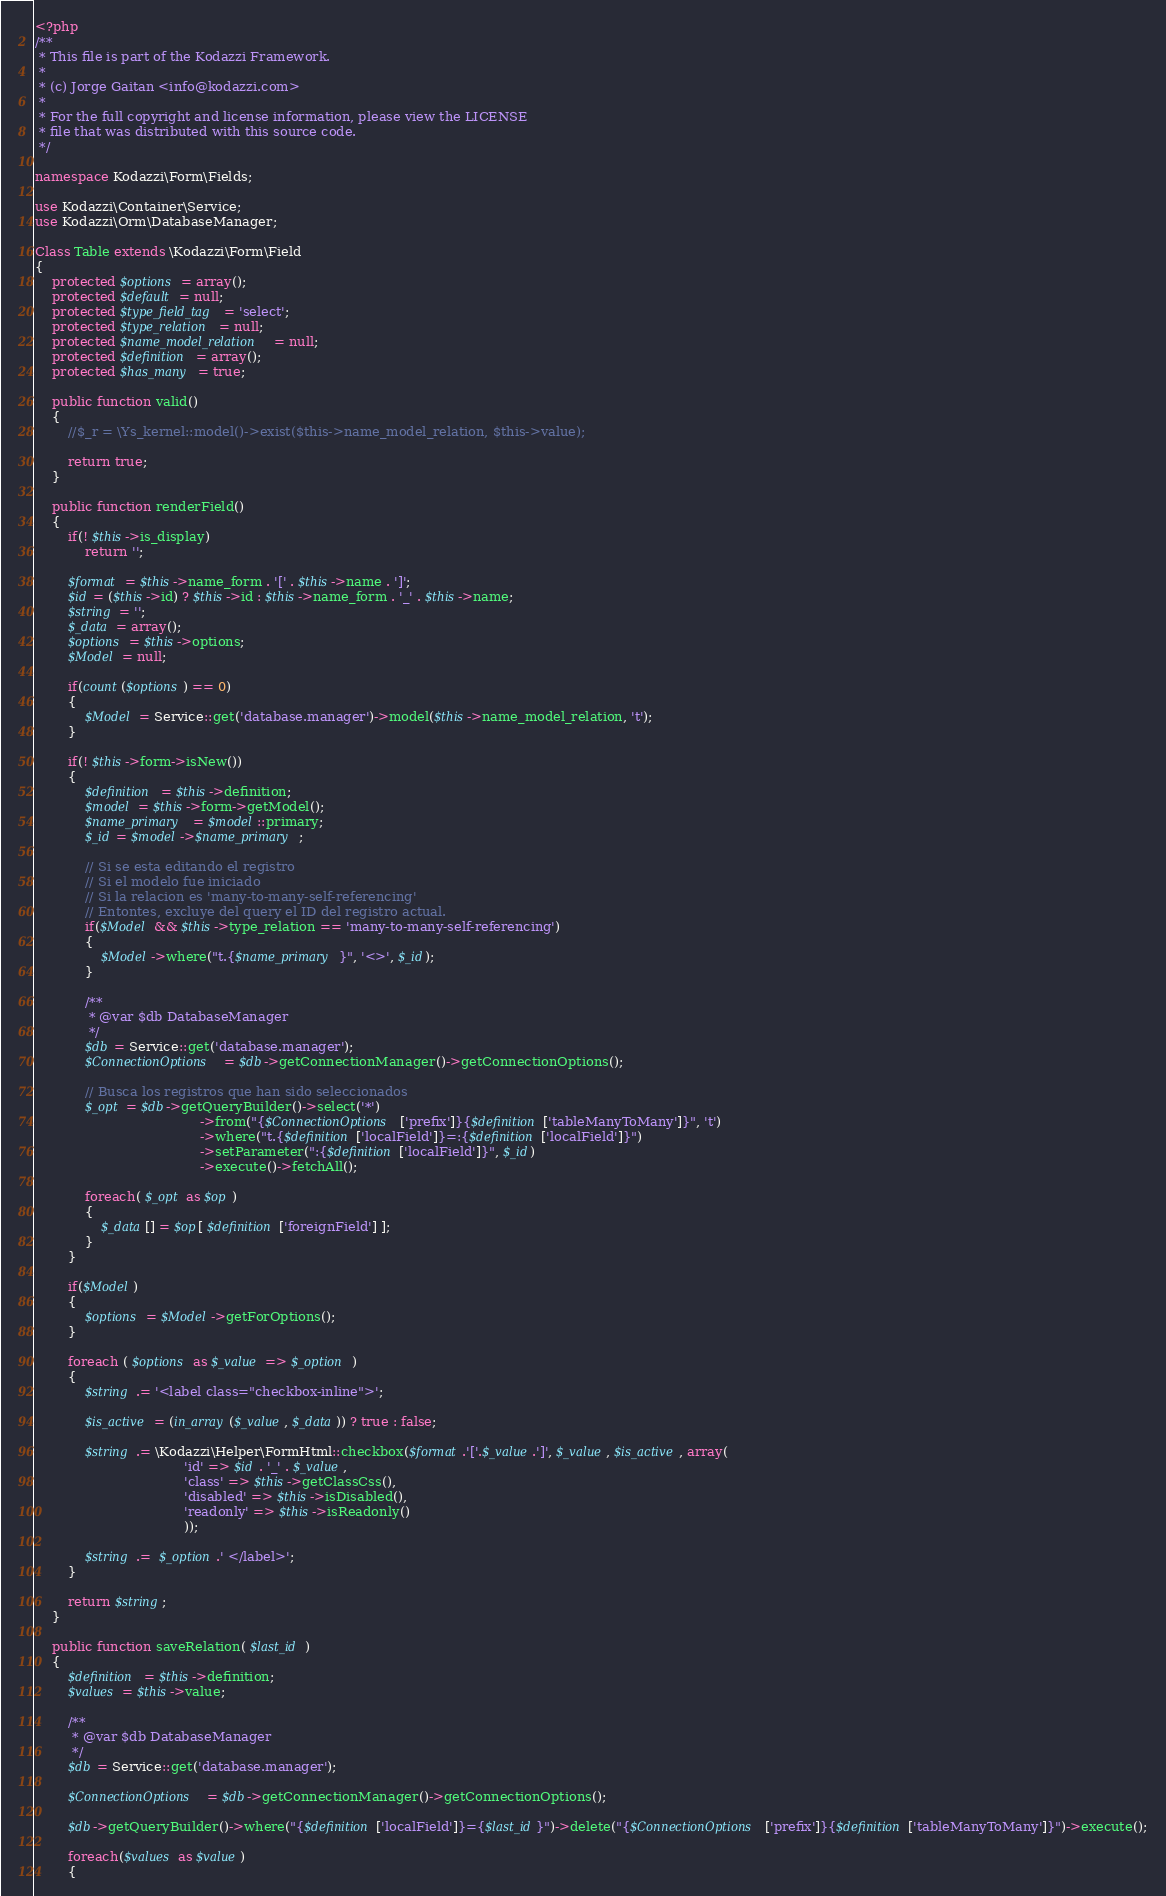<code> <loc_0><loc_0><loc_500><loc_500><_PHP_><?php
/**
 * This file is part of the Kodazzi Framework.
 *
 * (c) Jorge Gaitan <info@kodazzi.com>
 *
 * For the full copyright and license information, please view the LICENSE
 * file that was distributed with this source code.
 */

namespace Kodazzi\Form\Fields;

use Kodazzi\Container\Service;
use Kodazzi\Orm\DatabaseManager;

Class Table extends \Kodazzi\Form\Field
{
	protected $options = array();
	protected $default = null;
	protected $type_field_tag = 'select';
	protected $type_relation = null;
	protected $name_model_relation = null;
	protected $definition = array();
	protected $has_many = true;

	public function valid()
	{
		//$_r = \Ys_kernel::model()->exist($this->name_model_relation, $this->value);
		
		return true;
	}

	public function renderField()
	{
		if(! $this->is_display)
			return '';

		$format = $this->name_form . '[' . $this->name . ']';
        $id = ($this->id) ? $this->id : $this->name_form . '_' . $this->name;
		$string = '';
		$_data = array();
		$options = $this->options;
        $Model = null;

		if(count($options) == 0)
		{
            $Model = Service::get('database.manager')->model($this->name_model_relation, 't');
		}

		if(! $this->form->isNew())
		{
            $definition = $this->definition;
            $model = $this->form->getModel();
            $name_primary = $model::primary;
            $_id = $model->$name_primary;

            // Si se esta editando el registro
            // Si el modelo fue iniciado
            // Si la relacion es 'many-to-many-self-referencing'
            // Entontes, excluye del query el ID del registro actual.
            if($Model && $this->type_relation == 'many-to-many-self-referencing')
            {
                $Model->where("t.{$name_primary}", '<>', $_id);
            }

            /**
             * @var $db DatabaseManager
             */
            $db = Service::get('database.manager');
            $ConnectionOptions = $db->getConnectionManager()->getConnectionOptions();

            // Busca los registros que han sido seleccionados
            $_opt = $db->getQueryBuilder()->select('*')
                                        ->from("{$ConnectionOptions['prefix']}{$definition['tableManyToMany']}", 't')
                                        ->where("t.{$definition['localField']}=:{$definition['localField']}")
                                        ->setParameter(":{$definition['localField']}", $_id)
                                        ->execute()->fetchAll();

			foreach( $_opt as $op )
			{
				$_data[] = $op[ $definition['foreignField'] ];
			}
		}

        if($Model)
        {
            $options = $Model->getForOptions();
        }

		foreach ( $options as $_value => $_option )
		{
			$string .= '<label class="checkbox-inline">';

			$is_active = (in_array($_value, $_data)) ? true : false;

			$string .= \Kodazzi\Helper\FormHtml::checkbox($format.'['.$_value.']', $_value, $is_active, array(
									'id' => $id . '_' . $_value,
									'class' => $this->getClassCss(),
									'disabled' => $this->isDisabled(),
									'readonly' => $this->isReadonly()
									));

			$string .=  $_option.' </label>';
		}

		return $string;
	}
	
	public function saveRelation( $last_id )
	{
		$definition = $this->definition;
		$values = $this->value;

        /**
         * @var $db DatabaseManager
         */
        $db = Service::get('database.manager');

        $ConnectionOptions = $db->getConnectionManager()->getConnectionOptions();

        $db->getQueryBuilder()->where("{$definition['localField']}={$last_id}")->delete("{$ConnectionOptions['prefix']}{$definition['tableManyToMany']}")->execute();

		foreach($values as $value)
		{</code> 